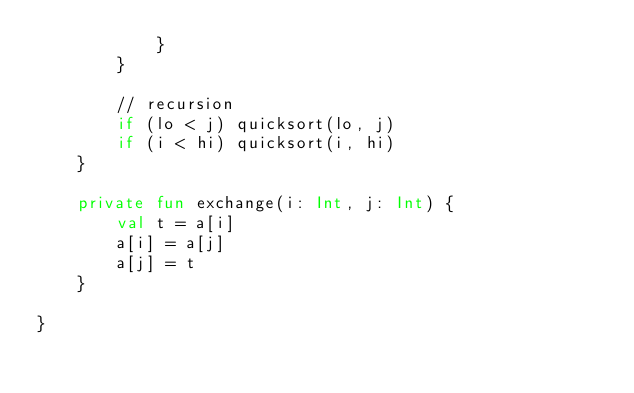Convert code to text. <code><loc_0><loc_0><loc_500><loc_500><_Kotlin_>            }
        }

        // recursion
        if (lo < j) quicksort(lo, j)
        if (i < hi) quicksort(i, hi)
    }

    private fun exchange(i: Int, j: Int) {
        val t = a[i]
        a[i] = a[j]
        a[j] = t
    }

}
</code> 